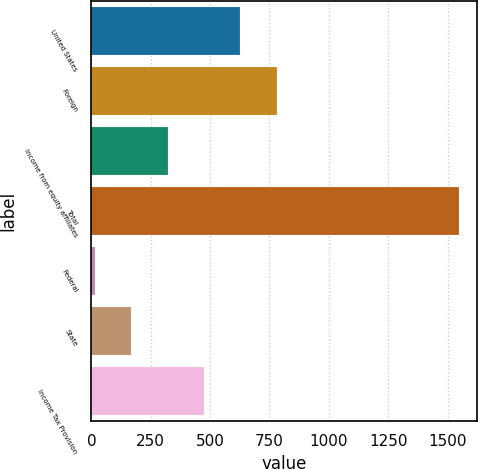Convert chart. <chart><loc_0><loc_0><loc_500><loc_500><bar_chart><fcel>United States<fcel>Foreign<fcel>Income from equity affiliates<fcel>Total<fcel>Federal<fcel>State<fcel>Income Tax Provision<nl><fcel>627.58<fcel>780.8<fcel>321.14<fcel>1546.9<fcel>14.7<fcel>167.92<fcel>474.36<nl></chart> 